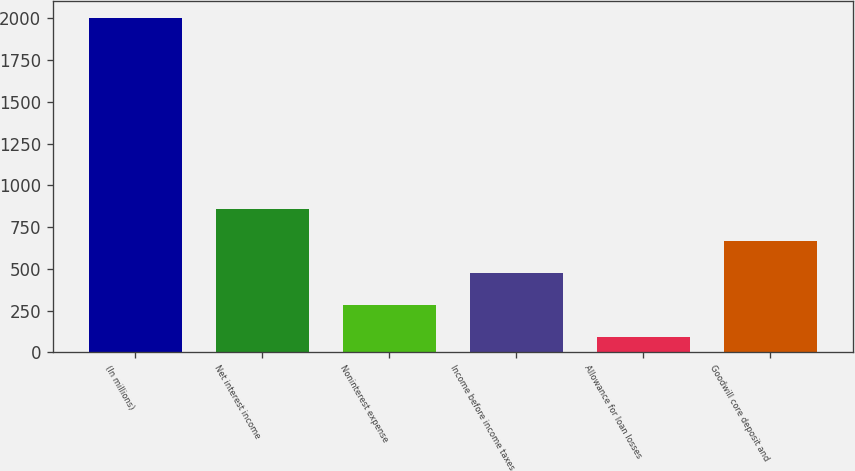<chart> <loc_0><loc_0><loc_500><loc_500><bar_chart><fcel>(In millions)<fcel>Net interest income<fcel>Noninterest expense<fcel>Income before income taxes<fcel>Allowance for loan losses<fcel>Goodwill core deposit and<nl><fcel>2005<fcel>856.6<fcel>282.4<fcel>473.8<fcel>91<fcel>665.2<nl></chart> 